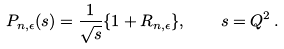Convert formula to latex. <formula><loc_0><loc_0><loc_500><loc_500>P _ { n , \epsilon } ( s ) = \frac { 1 } { \sqrt { s } } \{ 1 + R _ { n , \epsilon } \} , \quad s = Q ^ { 2 } \, .</formula> 